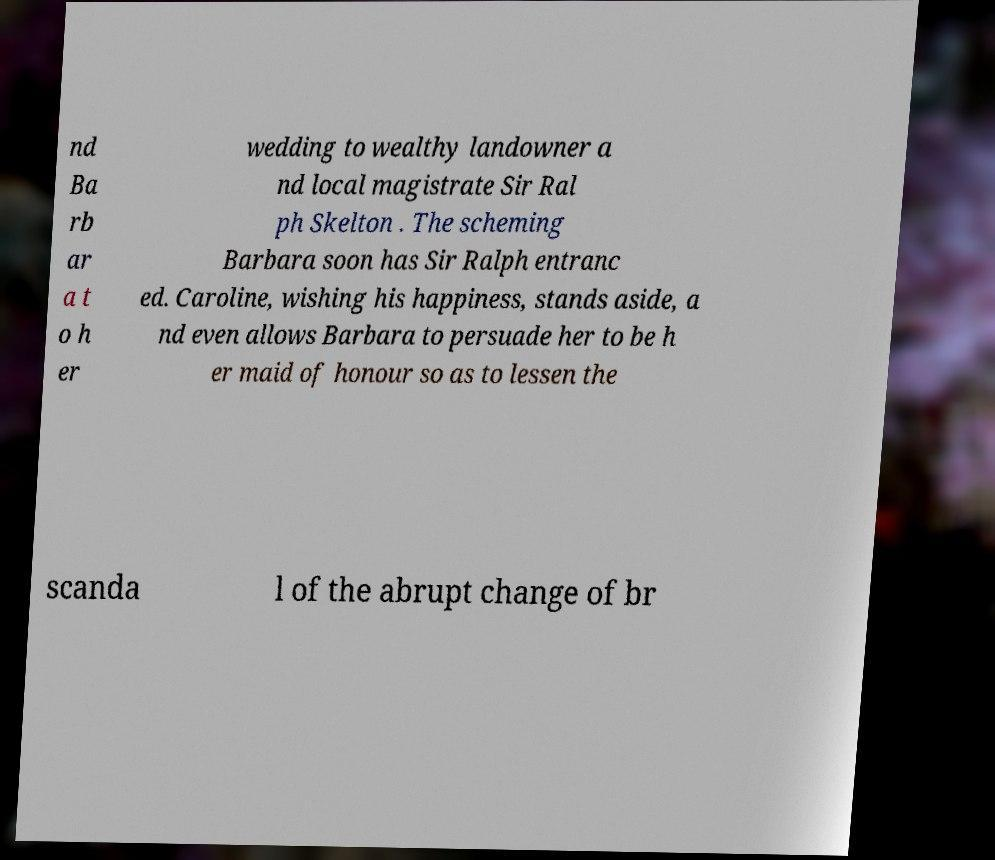Could you extract and type out the text from this image? nd Ba rb ar a t o h er wedding to wealthy landowner a nd local magistrate Sir Ral ph Skelton . The scheming Barbara soon has Sir Ralph entranc ed. Caroline, wishing his happiness, stands aside, a nd even allows Barbara to persuade her to be h er maid of honour so as to lessen the scanda l of the abrupt change of br 